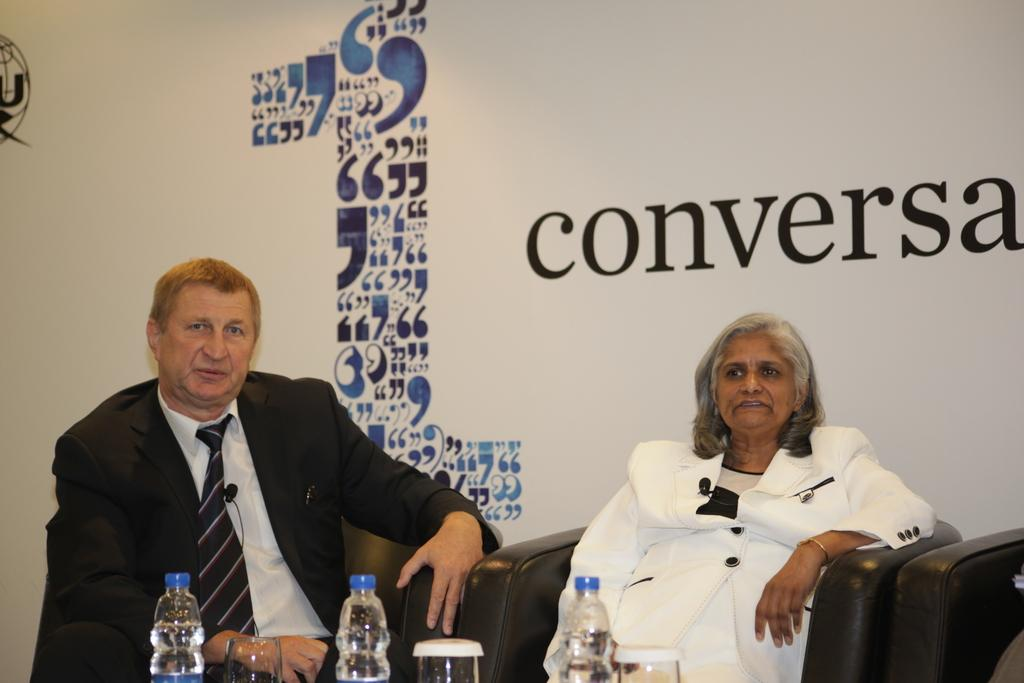Who are the people in the image? There is a man and a woman in the image. What are they doing in the image? The man and woman are seated on seater sofas. What objects are in front of them? There are bottles and glasses in front of them. What type of poison is being served in the glasses in the image? There is no indication of poison in the image; the glasses likely contain a beverage. 